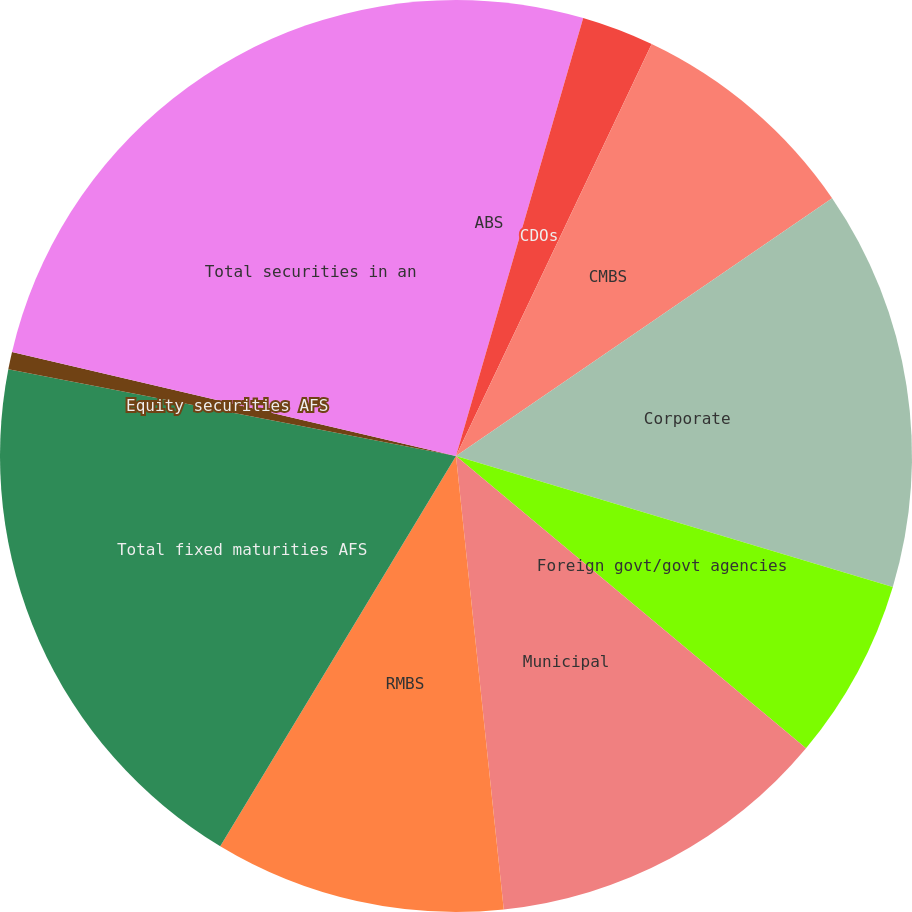Convert chart. <chart><loc_0><loc_0><loc_500><loc_500><pie_chart><fcel>ABS<fcel>CDOs<fcel>CMBS<fcel>Corporate<fcel>Foreign govt/govt agencies<fcel>Municipal<fcel>RMBS<fcel>Total fixed maturities AFS<fcel>Equity securities AFS<fcel>Total securities in an<nl><fcel>4.5%<fcel>2.56%<fcel>8.38%<fcel>14.2%<fcel>6.44%<fcel>12.26%<fcel>10.32%<fcel>19.4%<fcel>0.62%<fcel>21.34%<nl></chart> 